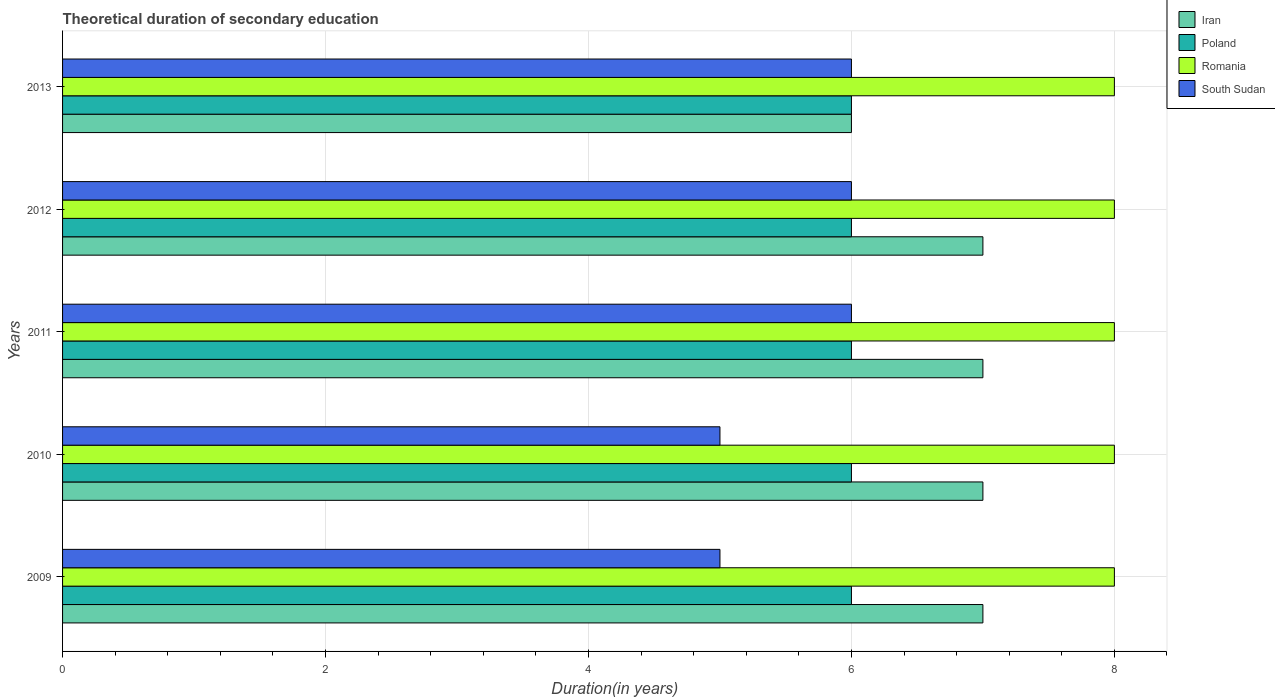Are the number of bars on each tick of the Y-axis equal?
Keep it short and to the point. Yes. How many bars are there on the 1st tick from the bottom?
Provide a succinct answer. 4. What is the label of the 4th group of bars from the top?
Your answer should be very brief. 2010. In how many cases, is the number of bars for a given year not equal to the number of legend labels?
Provide a succinct answer. 0. What is the total theoretical duration of secondary education in Poland in 2013?
Your answer should be compact. 6. Across all years, what is the maximum total theoretical duration of secondary education in Romania?
Make the answer very short. 8. What is the total total theoretical duration of secondary education in Poland in the graph?
Offer a terse response. 30. What is the average total theoretical duration of secondary education in Poland per year?
Your response must be concise. 6. In the year 2011, what is the difference between the total theoretical duration of secondary education in Romania and total theoretical duration of secondary education in Iran?
Your answer should be very brief. 1. In how many years, is the total theoretical duration of secondary education in Iran greater than 2 years?
Give a very brief answer. 5. What is the ratio of the total theoretical duration of secondary education in Romania in 2009 to that in 2013?
Offer a terse response. 1. Is the total theoretical duration of secondary education in Romania in 2010 less than that in 2013?
Provide a succinct answer. No. Is the difference between the total theoretical duration of secondary education in Romania in 2009 and 2011 greater than the difference between the total theoretical duration of secondary education in Iran in 2009 and 2011?
Give a very brief answer. No. What is the difference between the highest and the second highest total theoretical duration of secondary education in Iran?
Provide a succinct answer. 0. Is the sum of the total theoretical duration of secondary education in Romania in 2009 and 2013 greater than the maximum total theoretical duration of secondary education in South Sudan across all years?
Give a very brief answer. Yes. Is it the case that in every year, the sum of the total theoretical duration of secondary education in Poland and total theoretical duration of secondary education in Iran is greater than the sum of total theoretical duration of secondary education in South Sudan and total theoretical duration of secondary education in Romania?
Offer a very short reply. No. What does the 3rd bar from the bottom in 2010 represents?
Ensure brevity in your answer.  Romania. Are the values on the major ticks of X-axis written in scientific E-notation?
Your answer should be very brief. No. Does the graph contain any zero values?
Your answer should be very brief. No. Does the graph contain grids?
Your response must be concise. Yes. How are the legend labels stacked?
Provide a short and direct response. Vertical. What is the title of the graph?
Keep it short and to the point. Theoretical duration of secondary education. What is the label or title of the X-axis?
Your answer should be very brief. Duration(in years). What is the label or title of the Y-axis?
Provide a short and direct response. Years. What is the Duration(in years) in Iran in 2009?
Make the answer very short. 7. What is the Duration(in years) in Poland in 2009?
Your response must be concise. 6. What is the Duration(in years) in Poland in 2010?
Offer a very short reply. 6. What is the Duration(in years) of Romania in 2010?
Give a very brief answer. 8. What is the Duration(in years) in Iran in 2011?
Your response must be concise. 7. What is the Duration(in years) of Romania in 2011?
Give a very brief answer. 8. What is the Duration(in years) of South Sudan in 2011?
Your response must be concise. 6. What is the Duration(in years) of Romania in 2012?
Make the answer very short. 8. What is the Duration(in years) of South Sudan in 2012?
Your response must be concise. 6. What is the Duration(in years) of Iran in 2013?
Ensure brevity in your answer.  6. What is the Duration(in years) of Romania in 2013?
Provide a succinct answer. 8. What is the Duration(in years) of South Sudan in 2013?
Offer a very short reply. 6. Across all years, what is the maximum Duration(in years) in Poland?
Provide a succinct answer. 6. Across all years, what is the maximum Duration(in years) of South Sudan?
Provide a succinct answer. 6. Across all years, what is the minimum Duration(in years) in Iran?
Offer a terse response. 6. Across all years, what is the minimum Duration(in years) of Romania?
Offer a terse response. 8. What is the total Duration(in years) in Iran in the graph?
Ensure brevity in your answer.  34. What is the total Duration(in years) of South Sudan in the graph?
Offer a very short reply. 28. What is the difference between the Duration(in years) in Iran in 2009 and that in 2010?
Provide a succinct answer. 0. What is the difference between the Duration(in years) of Poland in 2009 and that in 2010?
Provide a short and direct response. 0. What is the difference between the Duration(in years) of Romania in 2009 and that in 2010?
Your response must be concise. 0. What is the difference between the Duration(in years) of South Sudan in 2009 and that in 2010?
Offer a very short reply. 0. What is the difference between the Duration(in years) in Iran in 2009 and that in 2011?
Ensure brevity in your answer.  0. What is the difference between the Duration(in years) of South Sudan in 2009 and that in 2011?
Make the answer very short. -1. What is the difference between the Duration(in years) of South Sudan in 2009 and that in 2012?
Provide a succinct answer. -1. What is the difference between the Duration(in years) in Poland in 2009 and that in 2013?
Your answer should be very brief. 0. What is the difference between the Duration(in years) in South Sudan in 2009 and that in 2013?
Your answer should be very brief. -1. What is the difference between the Duration(in years) in Romania in 2010 and that in 2011?
Offer a very short reply. 0. What is the difference between the Duration(in years) in Iran in 2010 and that in 2012?
Offer a very short reply. 0. What is the difference between the Duration(in years) of Poland in 2010 and that in 2012?
Give a very brief answer. 0. What is the difference between the Duration(in years) in Romania in 2010 and that in 2012?
Provide a short and direct response. 0. What is the difference between the Duration(in years) of Poland in 2010 and that in 2013?
Provide a short and direct response. 0. What is the difference between the Duration(in years) in Poland in 2011 and that in 2012?
Offer a terse response. 0. What is the difference between the Duration(in years) of Poland in 2011 and that in 2013?
Give a very brief answer. 0. What is the difference between the Duration(in years) in Iran in 2012 and that in 2013?
Offer a very short reply. 1. What is the difference between the Duration(in years) of South Sudan in 2012 and that in 2013?
Your answer should be compact. 0. What is the difference between the Duration(in years) of Iran in 2009 and the Duration(in years) of Poland in 2010?
Your answer should be compact. 1. What is the difference between the Duration(in years) in Iran in 2009 and the Duration(in years) in South Sudan in 2010?
Your answer should be very brief. 2. What is the difference between the Duration(in years) of Poland in 2009 and the Duration(in years) of South Sudan in 2010?
Provide a short and direct response. 1. What is the difference between the Duration(in years) of Romania in 2009 and the Duration(in years) of South Sudan in 2010?
Provide a succinct answer. 3. What is the difference between the Duration(in years) in Iran in 2009 and the Duration(in years) in Romania in 2011?
Ensure brevity in your answer.  -1. What is the difference between the Duration(in years) in Iran in 2009 and the Duration(in years) in South Sudan in 2011?
Your response must be concise. 1. What is the difference between the Duration(in years) in Poland in 2009 and the Duration(in years) in Romania in 2011?
Keep it short and to the point. -2. What is the difference between the Duration(in years) in Poland in 2009 and the Duration(in years) in South Sudan in 2011?
Offer a very short reply. 0. What is the difference between the Duration(in years) in Romania in 2009 and the Duration(in years) in South Sudan in 2011?
Your answer should be very brief. 2. What is the difference between the Duration(in years) of Iran in 2009 and the Duration(in years) of Poland in 2012?
Your answer should be very brief. 1. What is the difference between the Duration(in years) of Poland in 2009 and the Duration(in years) of Romania in 2012?
Make the answer very short. -2. What is the difference between the Duration(in years) of Iran in 2009 and the Duration(in years) of Poland in 2013?
Make the answer very short. 1. What is the difference between the Duration(in years) of Iran in 2009 and the Duration(in years) of Romania in 2013?
Your answer should be very brief. -1. What is the difference between the Duration(in years) of Iran in 2009 and the Duration(in years) of South Sudan in 2013?
Your answer should be compact. 1. What is the difference between the Duration(in years) in Poland in 2009 and the Duration(in years) in South Sudan in 2013?
Make the answer very short. 0. What is the difference between the Duration(in years) of Romania in 2009 and the Duration(in years) of South Sudan in 2013?
Make the answer very short. 2. What is the difference between the Duration(in years) of Iran in 2010 and the Duration(in years) of Poland in 2011?
Provide a succinct answer. 1. What is the difference between the Duration(in years) in Iran in 2010 and the Duration(in years) in South Sudan in 2011?
Your response must be concise. 1. What is the difference between the Duration(in years) of Poland in 2010 and the Duration(in years) of South Sudan in 2011?
Provide a short and direct response. 0. What is the difference between the Duration(in years) in Romania in 2010 and the Duration(in years) in South Sudan in 2011?
Provide a short and direct response. 2. What is the difference between the Duration(in years) of Poland in 2010 and the Duration(in years) of Romania in 2012?
Provide a short and direct response. -2. What is the difference between the Duration(in years) of Iran in 2010 and the Duration(in years) of Poland in 2013?
Offer a very short reply. 1. What is the difference between the Duration(in years) of Iran in 2010 and the Duration(in years) of Romania in 2013?
Your answer should be compact. -1. What is the difference between the Duration(in years) in Iran in 2010 and the Duration(in years) in South Sudan in 2013?
Your answer should be compact. 1. What is the difference between the Duration(in years) of Poland in 2010 and the Duration(in years) of South Sudan in 2013?
Provide a short and direct response. 0. What is the difference between the Duration(in years) of Iran in 2011 and the Duration(in years) of Romania in 2012?
Ensure brevity in your answer.  -1. What is the difference between the Duration(in years) in Iran in 2011 and the Duration(in years) in South Sudan in 2012?
Keep it short and to the point. 1. What is the difference between the Duration(in years) in Poland in 2011 and the Duration(in years) in Romania in 2012?
Your answer should be compact. -2. What is the difference between the Duration(in years) of Iran in 2011 and the Duration(in years) of Poland in 2013?
Give a very brief answer. 1. What is the difference between the Duration(in years) of Iran in 2011 and the Duration(in years) of Romania in 2013?
Give a very brief answer. -1. What is the difference between the Duration(in years) in Romania in 2011 and the Duration(in years) in South Sudan in 2013?
Offer a terse response. 2. What is the difference between the Duration(in years) of Iran in 2012 and the Duration(in years) of Poland in 2013?
Ensure brevity in your answer.  1. What is the difference between the Duration(in years) in Iran in 2012 and the Duration(in years) in Romania in 2013?
Offer a terse response. -1. What is the difference between the Duration(in years) of Iran in 2012 and the Duration(in years) of South Sudan in 2013?
Your answer should be compact. 1. What is the difference between the Duration(in years) of Poland in 2012 and the Duration(in years) of Romania in 2013?
Ensure brevity in your answer.  -2. What is the difference between the Duration(in years) in Romania in 2012 and the Duration(in years) in South Sudan in 2013?
Ensure brevity in your answer.  2. What is the average Duration(in years) of Iran per year?
Your answer should be compact. 6.8. What is the average Duration(in years) in Poland per year?
Offer a very short reply. 6. What is the average Duration(in years) in Romania per year?
Provide a short and direct response. 8. What is the average Duration(in years) in South Sudan per year?
Offer a very short reply. 5.6. In the year 2009, what is the difference between the Duration(in years) of Iran and Duration(in years) of Poland?
Ensure brevity in your answer.  1. In the year 2009, what is the difference between the Duration(in years) of Iran and Duration(in years) of South Sudan?
Offer a terse response. 2. In the year 2010, what is the difference between the Duration(in years) of Iran and Duration(in years) of Poland?
Offer a terse response. 1. In the year 2010, what is the difference between the Duration(in years) in Iran and Duration(in years) in Romania?
Offer a very short reply. -1. In the year 2011, what is the difference between the Duration(in years) of Iran and Duration(in years) of Poland?
Provide a succinct answer. 1. In the year 2011, what is the difference between the Duration(in years) in Iran and Duration(in years) in South Sudan?
Keep it short and to the point. 1. In the year 2011, what is the difference between the Duration(in years) in Poland and Duration(in years) in South Sudan?
Ensure brevity in your answer.  0. In the year 2012, what is the difference between the Duration(in years) in Iran and Duration(in years) in South Sudan?
Provide a short and direct response. 1. In the year 2012, what is the difference between the Duration(in years) in Poland and Duration(in years) in Romania?
Provide a short and direct response. -2. In the year 2012, what is the difference between the Duration(in years) of Romania and Duration(in years) of South Sudan?
Ensure brevity in your answer.  2. In the year 2013, what is the difference between the Duration(in years) of Iran and Duration(in years) of Poland?
Your response must be concise. 0. In the year 2013, what is the difference between the Duration(in years) of Iran and Duration(in years) of South Sudan?
Offer a very short reply. 0. What is the ratio of the Duration(in years) of Poland in 2009 to that in 2010?
Provide a succinct answer. 1. What is the ratio of the Duration(in years) of Iran in 2009 to that in 2011?
Offer a very short reply. 1. What is the ratio of the Duration(in years) in Poland in 2009 to that in 2011?
Offer a terse response. 1. What is the ratio of the Duration(in years) of Romania in 2009 to that in 2011?
Give a very brief answer. 1. What is the ratio of the Duration(in years) of Poland in 2009 to that in 2012?
Give a very brief answer. 1. What is the ratio of the Duration(in years) in Romania in 2009 to that in 2012?
Your response must be concise. 1. What is the ratio of the Duration(in years) of South Sudan in 2009 to that in 2012?
Your answer should be very brief. 0.83. What is the ratio of the Duration(in years) of South Sudan in 2009 to that in 2013?
Your answer should be very brief. 0.83. What is the ratio of the Duration(in years) in Iran in 2010 to that in 2011?
Your answer should be compact. 1. What is the ratio of the Duration(in years) of Poland in 2010 to that in 2011?
Your answer should be compact. 1. What is the ratio of the Duration(in years) in South Sudan in 2010 to that in 2011?
Provide a succinct answer. 0.83. What is the ratio of the Duration(in years) in Poland in 2010 to that in 2013?
Ensure brevity in your answer.  1. What is the ratio of the Duration(in years) of Romania in 2011 to that in 2012?
Provide a short and direct response. 1. What is the ratio of the Duration(in years) of Iran in 2011 to that in 2013?
Keep it short and to the point. 1.17. What is the ratio of the Duration(in years) in Romania in 2011 to that in 2013?
Provide a succinct answer. 1. What is the ratio of the Duration(in years) of Iran in 2012 to that in 2013?
Make the answer very short. 1.17. What is the ratio of the Duration(in years) of Poland in 2012 to that in 2013?
Make the answer very short. 1. What is the ratio of the Duration(in years) of Romania in 2012 to that in 2013?
Give a very brief answer. 1. What is the ratio of the Duration(in years) of South Sudan in 2012 to that in 2013?
Keep it short and to the point. 1. What is the difference between the highest and the second highest Duration(in years) of Poland?
Offer a terse response. 0. What is the difference between the highest and the second highest Duration(in years) of Romania?
Your answer should be compact. 0. What is the difference between the highest and the second highest Duration(in years) of South Sudan?
Provide a succinct answer. 0. 